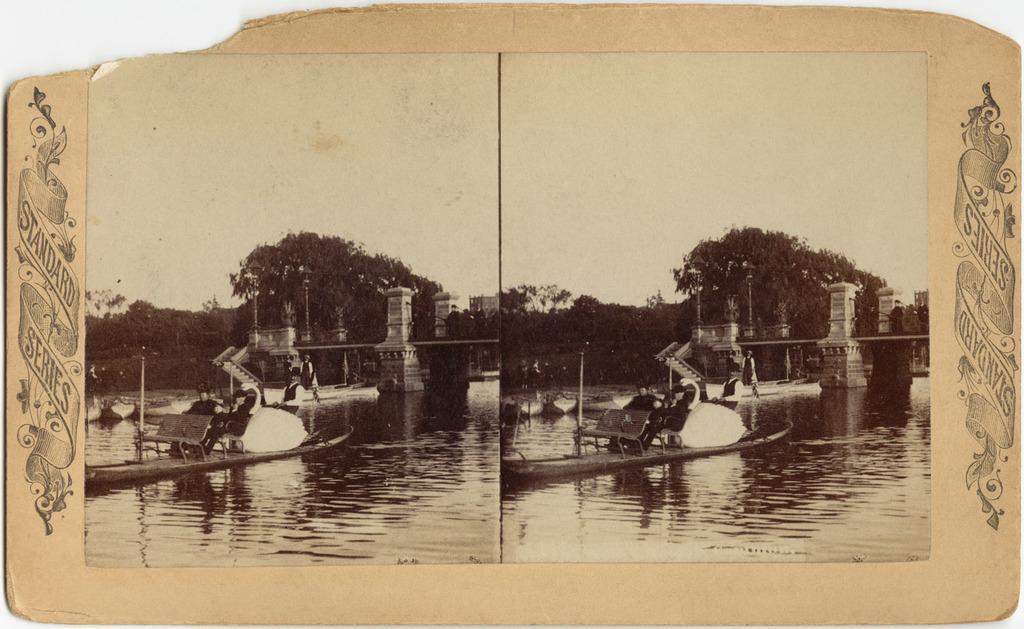Please provide a concise description of this image. In this image I can see a black and white picture on the white colored surface. In the picture I can see few persons sitting on a boat which is on the surface of the water. In the background I can see few trees, few buildings and the sky. 